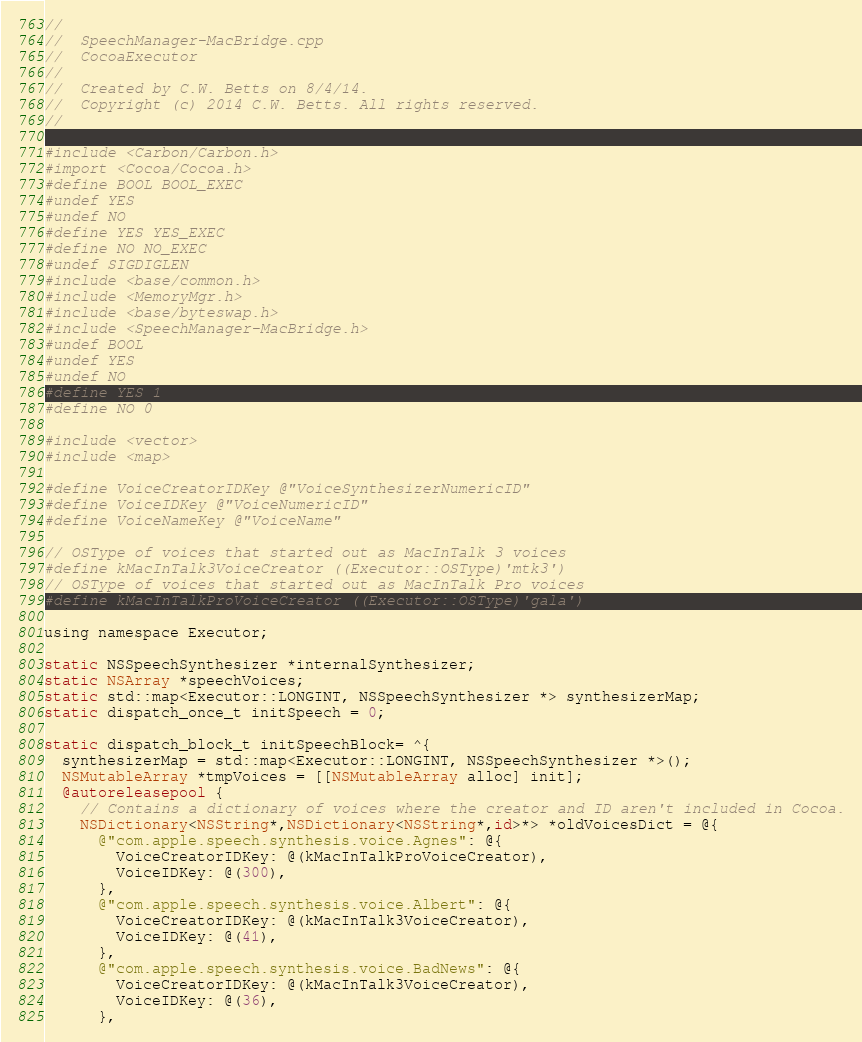<code> <loc_0><loc_0><loc_500><loc_500><_ObjectiveC_>//
//  SpeechManager-MacBridge.cpp
//  CocoaExecutor
//
//  Created by C.W. Betts on 8/4/14.
//  Copyright (c) 2014 C.W. Betts. All rights reserved.
//

#include <Carbon/Carbon.h>
#import <Cocoa/Cocoa.h>
#define BOOL BOOL_EXEC
#undef YES
#undef NO
#define YES YES_EXEC
#define NO NO_EXEC
#undef SIGDIGLEN
#include <base/common.h>
#include <MemoryMgr.h>
#include <base/byteswap.h>
#include <SpeechManager-MacBridge.h>
#undef BOOL
#undef YES
#undef NO
#define YES 1
#define NO 0

#include <vector>
#include <map>

#define VoiceCreatorIDKey @"VoiceSynthesizerNumericID"
#define VoiceIDKey @"VoiceNumericID"
#define VoiceNameKey @"VoiceName"

// OSType of voices that started out as MacInTalk 3 voices
#define kMacInTalk3VoiceCreator ((Executor::OSType)'mtk3')
// OSType of voices that started out as MacInTalk Pro voices
#define kMacInTalkProVoiceCreator ((Executor::OSType)'gala')

using namespace Executor;

static NSSpeechSynthesizer *internalSynthesizer;
static NSArray *speechVoices;
static std::map<Executor::LONGINT, NSSpeechSynthesizer *> synthesizerMap;
static dispatch_once_t initSpeech = 0;

static dispatch_block_t initSpeechBlock= ^{
  synthesizerMap = std::map<Executor::LONGINT, NSSpeechSynthesizer *>();
  NSMutableArray *tmpVoices = [[NSMutableArray alloc] init];
  @autoreleasepool {
    // Contains a dictionary of voices where the creator and ID aren't included in Cocoa.
    NSDictionary<NSString*,NSDictionary<NSString*,id>*> *oldVoicesDict = @{
      @"com.apple.speech.synthesis.voice.Agnes": @{
        VoiceCreatorIDKey: @(kMacInTalkProVoiceCreator),
        VoiceIDKey: @(300),
      },
      @"com.apple.speech.synthesis.voice.Albert": @{
        VoiceCreatorIDKey: @(kMacInTalk3VoiceCreator),
        VoiceIDKey: @(41),
      },
      @"com.apple.speech.synthesis.voice.BadNews": @{
        VoiceCreatorIDKey: @(kMacInTalk3VoiceCreator),
        VoiceIDKey: @(36),
      },</code> 